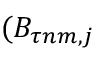Convert formula to latex. <formula><loc_0><loc_0><loc_500><loc_500>( B _ { \tau n m , j }</formula> 